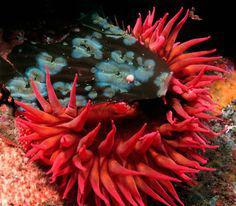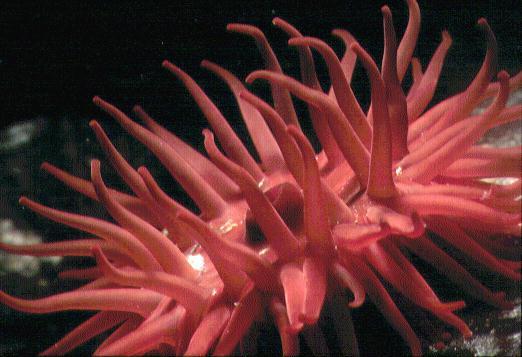The first image is the image on the left, the second image is the image on the right. Assess this claim about the two images: "there is a clown fish in the image on the right". Correct or not? Answer yes or no. No. The first image is the image on the left, the second image is the image on the right. For the images displayed, is the sentence "There is a clownfish in at least one image." factually correct? Answer yes or no. No. 